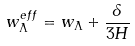<formula> <loc_0><loc_0><loc_500><loc_500>w _ { \Lambda } ^ { e f f } = w _ { \Lambda } + \frac { \delta } { 3 H }</formula> 